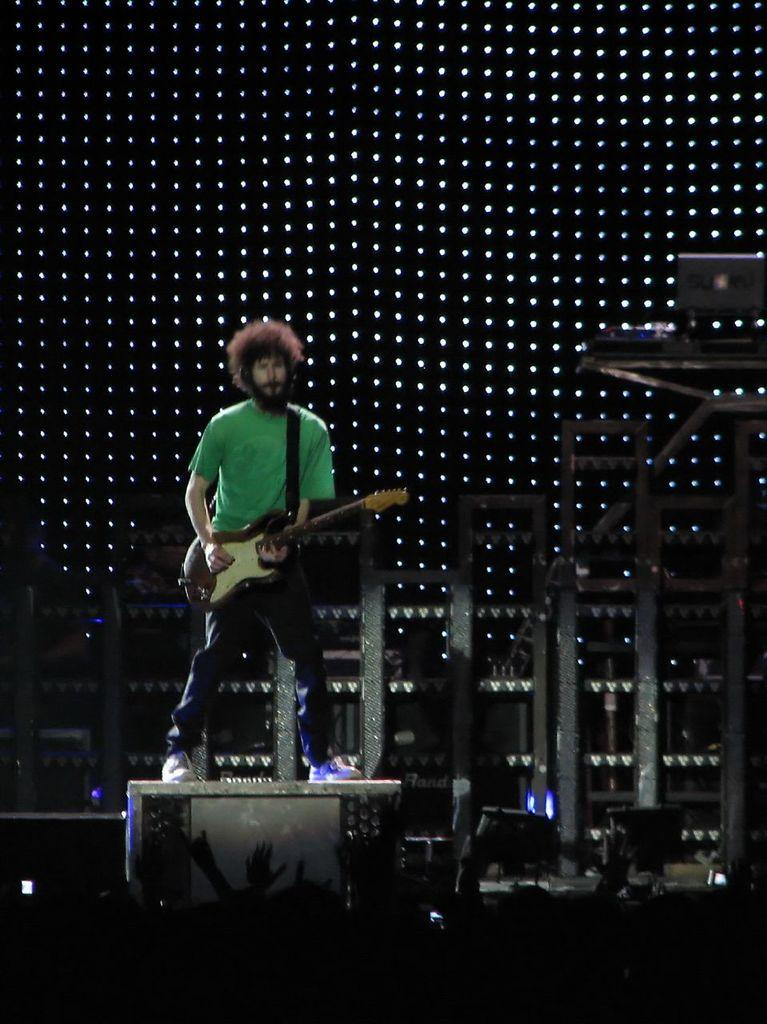What is the main subject of the image? The main subject of the image is a man. What is the man doing in the image? The man is standing and playing a guitar. What can be seen in the background of the image? There is a screen in the background of the image. What shape is the cracker that the man is holding in the image? There is no cracker present in the image; the man is playing a guitar. 